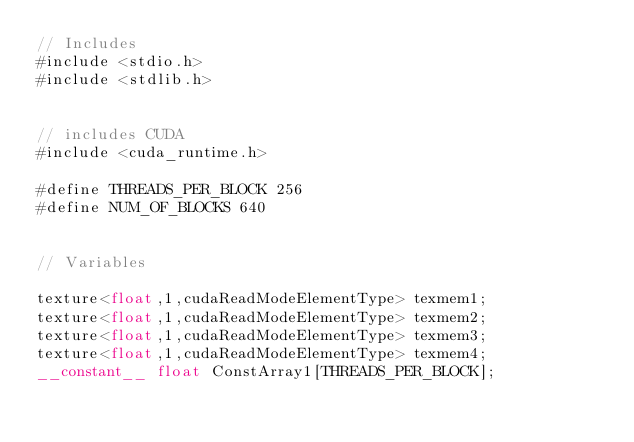<code> <loc_0><loc_0><loc_500><loc_500><_Cuda_>// Includes
#include <stdio.h>
#include <stdlib.h>


// includes CUDA
#include <cuda_runtime.h>

#define THREADS_PER_BLOCK 256
#define NUM_OF_BLOCKS 640


// Variables

texture<float,1,cudaReadModeElementType> texmem1;
texture<float,1,cudaReadModeElementType> texmem2;
texture<float,1,cudaReadModeElementType> texmem3;
texture<float,1,cudaReadModeElementType> texmem4;
__constant__ float ConstArray1[THREADS_PER_BLOCK];</code> 